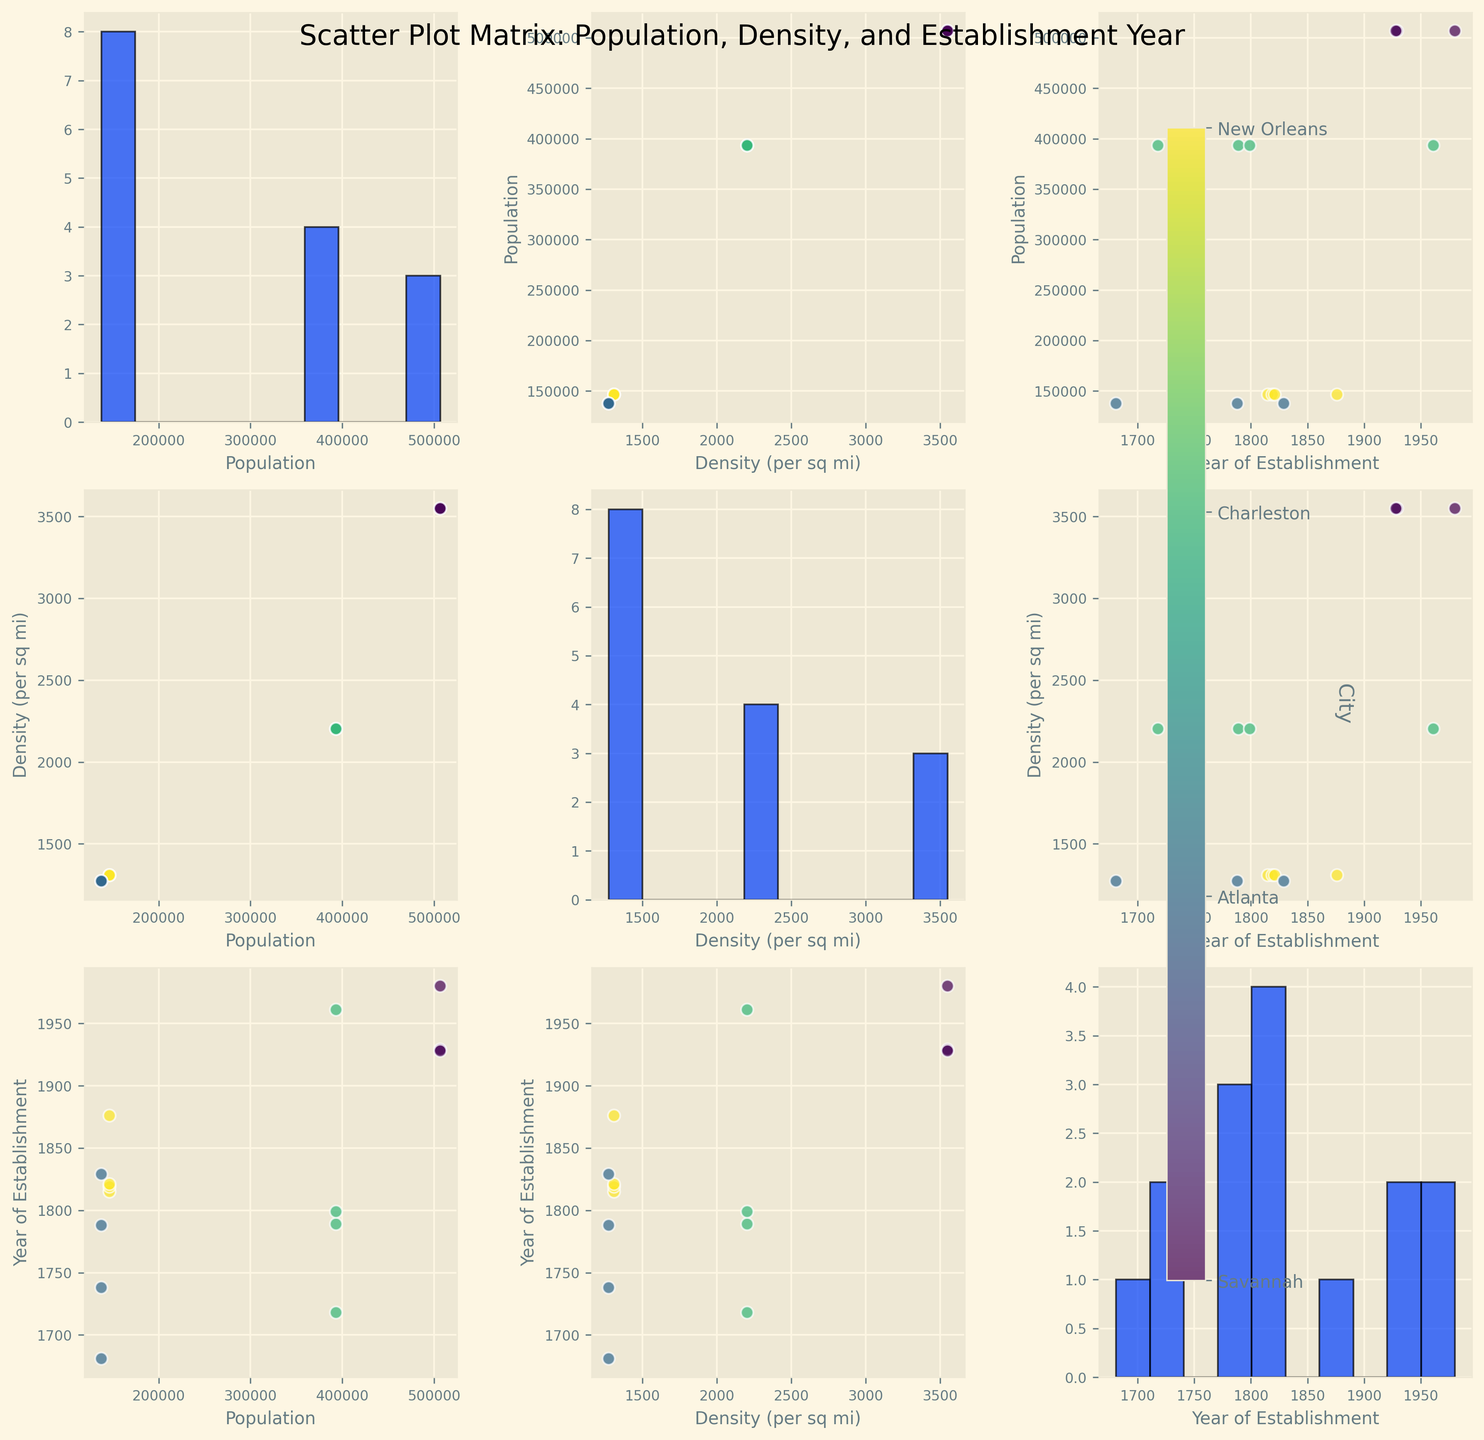What is the title of the figure? The title of the figure is displayed prominently at the top of the plot. It reads "Scatter Plot Matrix: Population, Density, and Establishment Year".
Answer: Scatter Plot Matrix: Population, Density, and Establishment Year How many different cities are represented in the data? We can count the unique labels in the color bar legend, or the unique categories in the scatter points. The cities mentioned are Savannah, Atlanta, Charleston, and New Orleans.
Answer: 4 What is the range of establishment years shown in the histograms? Looking at the histogram in the diagonal for "Year of Establishment", we can identify the minimum and maximum year values. The oldest landmark appears to be from 1681 and the most recent from 1980.
Answer: 1681 to 1980 Which city has the highest Population Density? By checking the scatter plots that involve "Density (per sq mi)", we can observe the data points. The color-coded legend helps us to identify the density values. Atlanta has the highest density per square mile among the displayed cities.
Answer: Atlanta Is there a trend between Population Density and Year of Establishment? Examining the scatter plot between "Density (per sq mi)" and "Year of Establishment", we look for any visible trend. Based on the scatter points, there doesn't appear to be a clear trend correlating density and year of establishment.
Answer: No clear trend What is the average year of establishment for historical landmarks in Savannah? In the histogram of "Year of Establishment", identify and sum the years corresponding to Savannah, and then divide by the number of landmarks (4). The landmarks' years are 1815, 1819, 1876, and 1821. (1815 + 1819 + 1876 + 1821) / 4 = 1832.75
Answer: 1832.75 Which city has landmarks that span the widest range of establishment years? Compare the range of years for each city by examining the data points in the scatter plots related to "Year of Establishment". New Orleans' landmarks span from 1718 to 1961, creating the widest range.
Answer: New Orleans Are there more historical landmarks established before or after 1800 in Charleston? Count the number of data points for Charleston in the scatter plots associated with "Year of Establishment". Charleston's landmarks are from 1681, 1738, 1788, and 1829, showing 3 before and 1 after 1800.
Answer: More before 1800 How does the population affect the number of landmarks in the cities? Compare the cities' population sizes and their number of landmarks. Population is checked in the scatter plots involving "Population". Savannah and Charleston, with lower populations, have multiple landmarks, while the higher population cities Atlanta and New Orleans also have multiple landmarks. Therefore, there isn't a clear population-size impact on the number of landmarks.
Answer: No clear effect Between which two cities is the difference in Population Density the smallest? Inspect the scatter plots involving "Density (per sq mi)" and compare the values for the closest pair. Savannah (1309) and Charleston (1273) have the smallest density difference.
Answer: Savannah and Charleston 